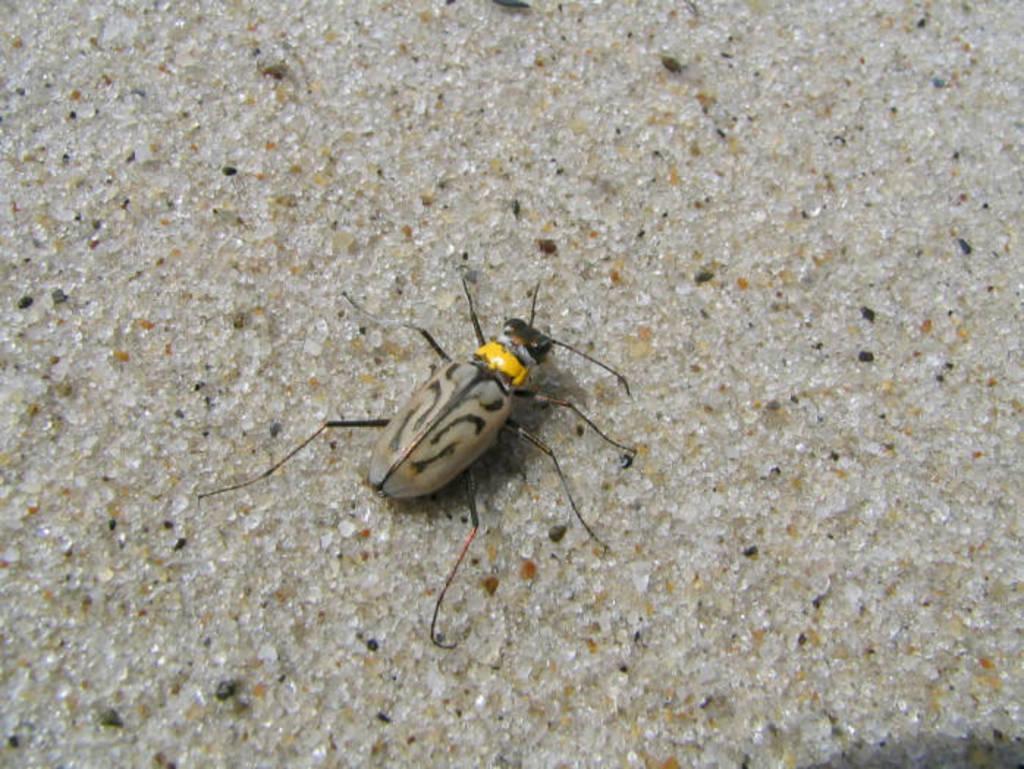Please provide a concise description of this image. In the image there is an insect on the floor. 